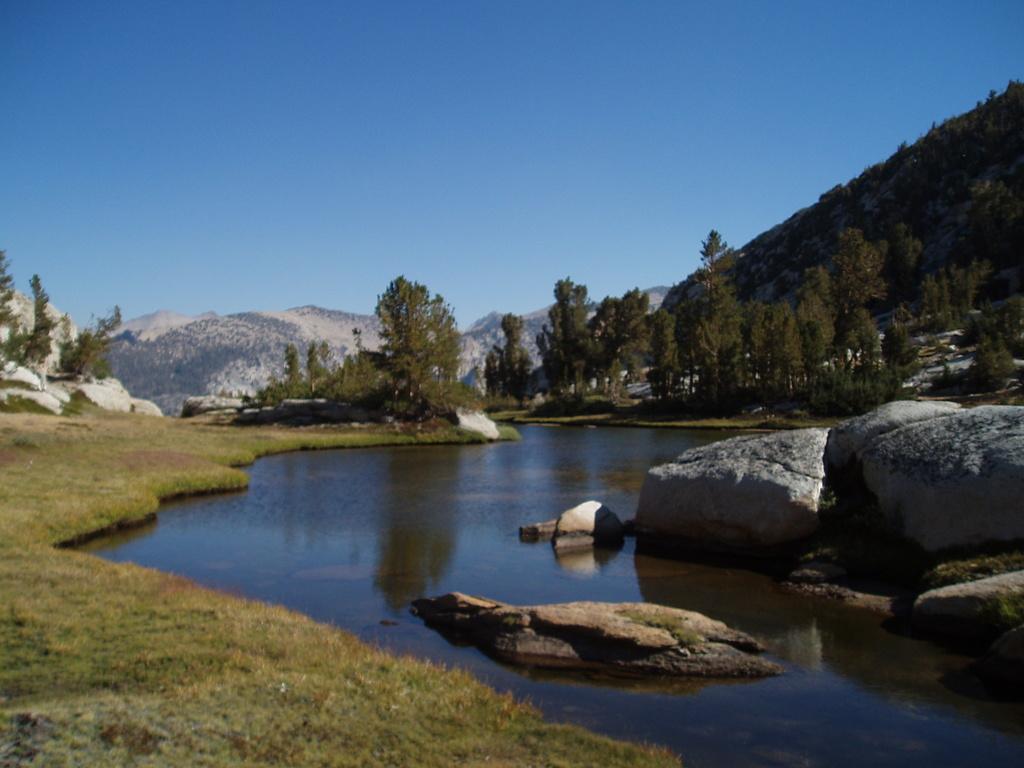In one or two sentences, can you explain what this image depicts? In the foreground of this image, there is water, stones and the grass. In the background, there are trees, mountains and on the top, there is the sky. 